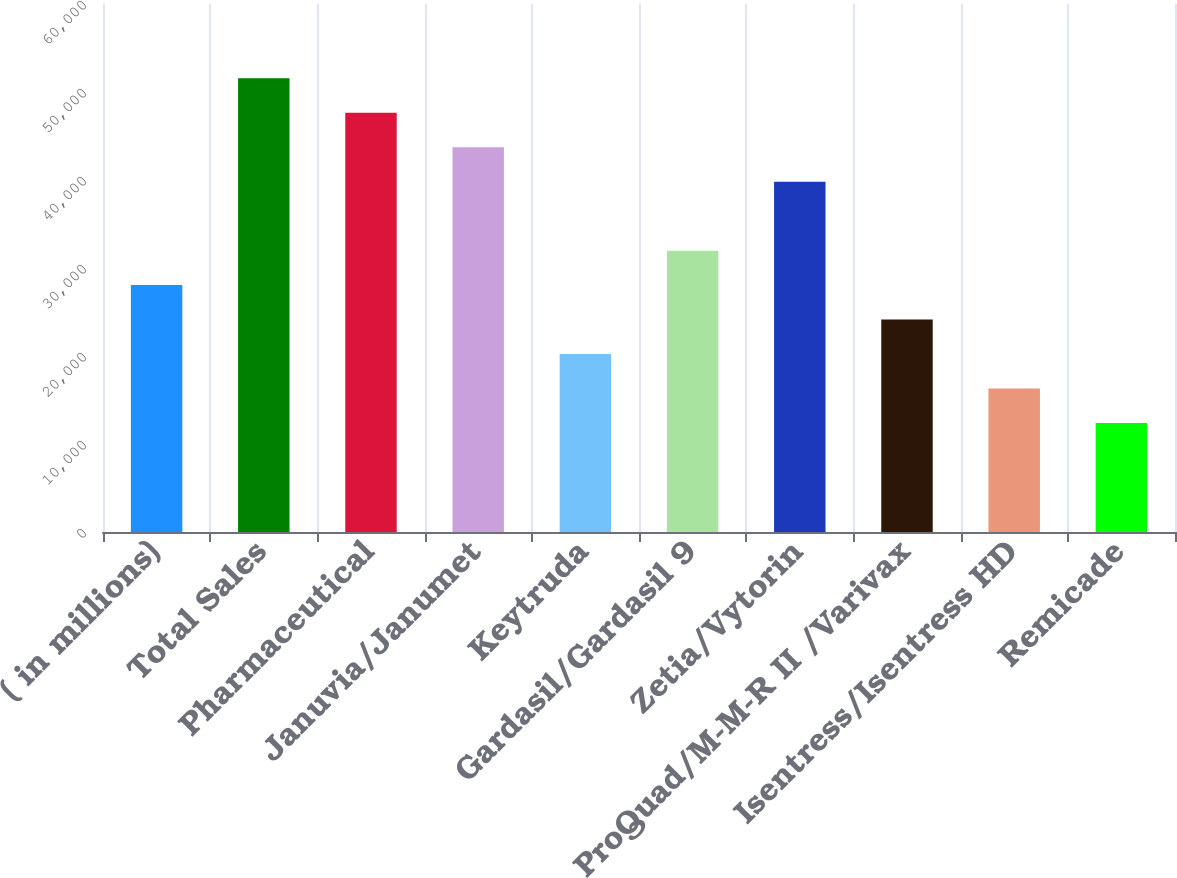<chart> <loc_0><loc_0><loc_500><loc_500><bar_chart><fcel>( in millions)<fcel>Total Sales<fcel>Pharmaceutical<fcel>Januvia/Janumet<fcel>Keytruda<fcel>Gardasil/Gardasil 9<fcel>Zetia/Vytorin<fcel>ProQuad/M-M-R II /Varivax<fcel>Isentress/Isentress HD<fcel>Remicade<nl><fcel>28057.2<fcel>51556.8<fcel>47640.2<fcel>43723.6<fcel>20224<fcel>31973.8<fcel>39807<fcel>24140.6<fcel>16307.4<fcel>12390.8<nl></chart> 